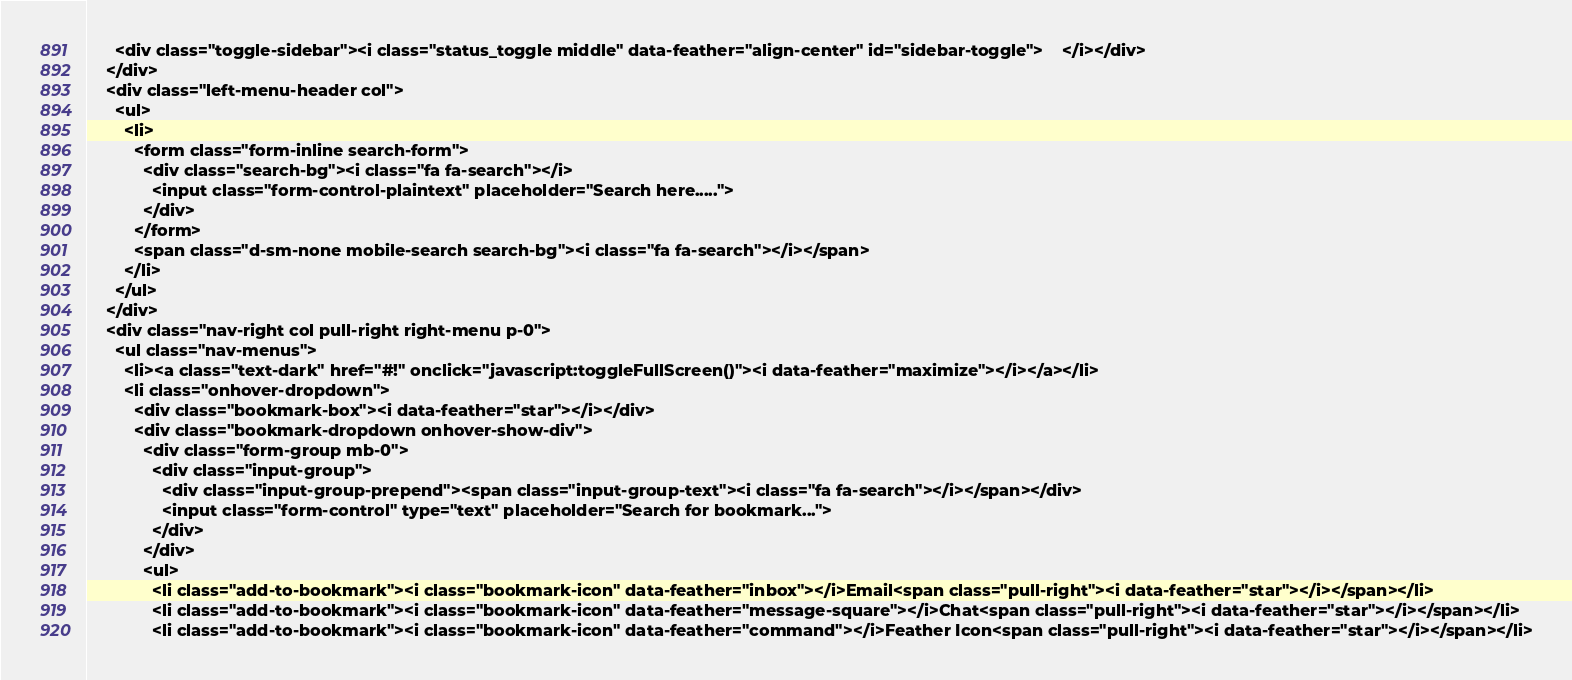<code> <loc_0><loc_0><loc_500><loc_500><_PHP_>      <div class="toggle-sidebar"><i class="status_toggle middle" data-feather="align-center" id="sidebar-toggle">    </i></div>
    </div>
    <div class="left-menu-header col">
      <ul>
        <li>
          <form class="form-inline search-form">
            <div class="search-bg"><i class="fa fa-search"></i>
              <input class="form-control-plaintext" placeholder="Search here.....">
            </div>
          </form>
          <span class="d-sm-none mobile-search search-bg"><i class="fa fa-search"></i></span>
        </li>
      </ul>
    </div>
    <div class="nav-right col pull-right right-menu p-0">
      <ul class="nav-menus">
        <li><a class="text-dark" href="#!" onclick="javascript:toggleFullScreen()"><i data-feather="maximize"></i></a></li>
        <li class="onhover-dropdown">
          <div class="bookmark-box"><i data-feather="star"></i></div>
          <div class="bookmark-dropdown onhover-show-div">
            <div class="form-group mb-0">
              <div class="input-group">
                <div class="input-group-prepend"><span class="input-group-text"><i class="fa fa-search"></i></span></div>
                <input class="form-control" type="text" placeholder="Search for bookmark...">
              </div>
            </div>
            <ul>
              <li class="add-to-bookmark"><i class="bookmark-icon" data-feather="inbox"></i>Email<span class="pull-right"><i data-feather="star"></i></span></li>
              <li class="add-to-bookmark"><i class="bookmark-icon" data-feather="message-square"></i>Chat<span class="pull-right"><i data-feather="star"></i></span></li>
              <li class="add-to-bookmark"><i class="bookmark-icon" data-feather="command"></i>Feather Icon<span class="pull-right"><i data-feather="star"></i></span></li></code> 